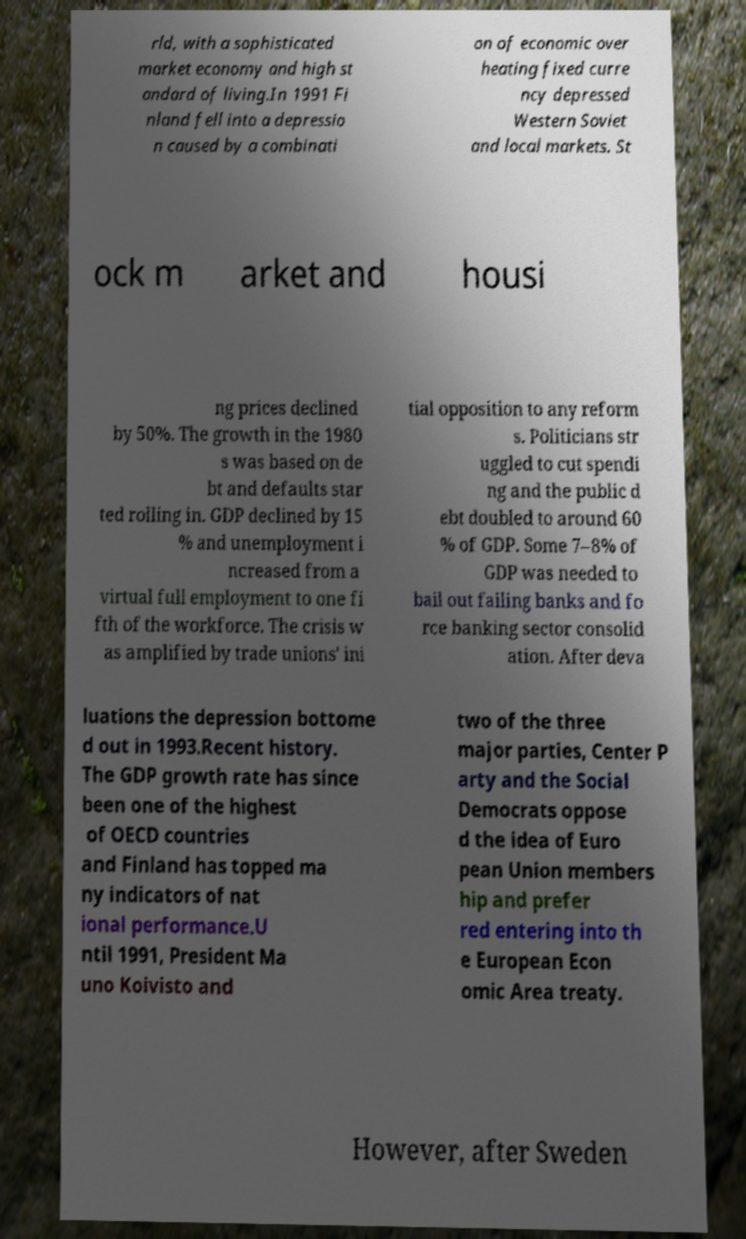Please identify and transcribe the text found in this image. rld, with a sophisticated market economy and high st andard of living.In 1991 Fi nland fell into a depressio n caused by a combinati on of economic over heating fixed curre ncy depressed Western Soviet and local markets. St ock m arket and housi ng prices declined by 50%. The growth in the 1980 s was based on de bt and defaults star ted rolling in. GDP declined by 15 % and unemployment i ncreased from a virtual full employment to one fi fth of the workforce. The crisis w as amplified by trade unions' ini tial opposition to any reform s. Politicians str uggled to cut spendi ng and the public d ebt doubled to around 60 % of GDP. Some 7–8% of GDP was needed to bail out failing banks and fo rce banking sector consolid ation. After deva luations the depression bottome d out in 1993.Recent history. The GDP growth rate has since been one of the highest of OECD countries and Finland has topped ma ny indicators of nat ional performance.U ntil 1991, President Ma uno Koivisto and two of the three major parties, Center P arty and the Social Democrats oppose d the idea of Euro pean Union members hip and prefer red entering into th e European Econ omic Area treaty. However, after Sweden 